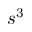Convert formula to latex. <formula><loc_0><loc_0><loc_500><loc_500>s ^ { 3 }</formula> 